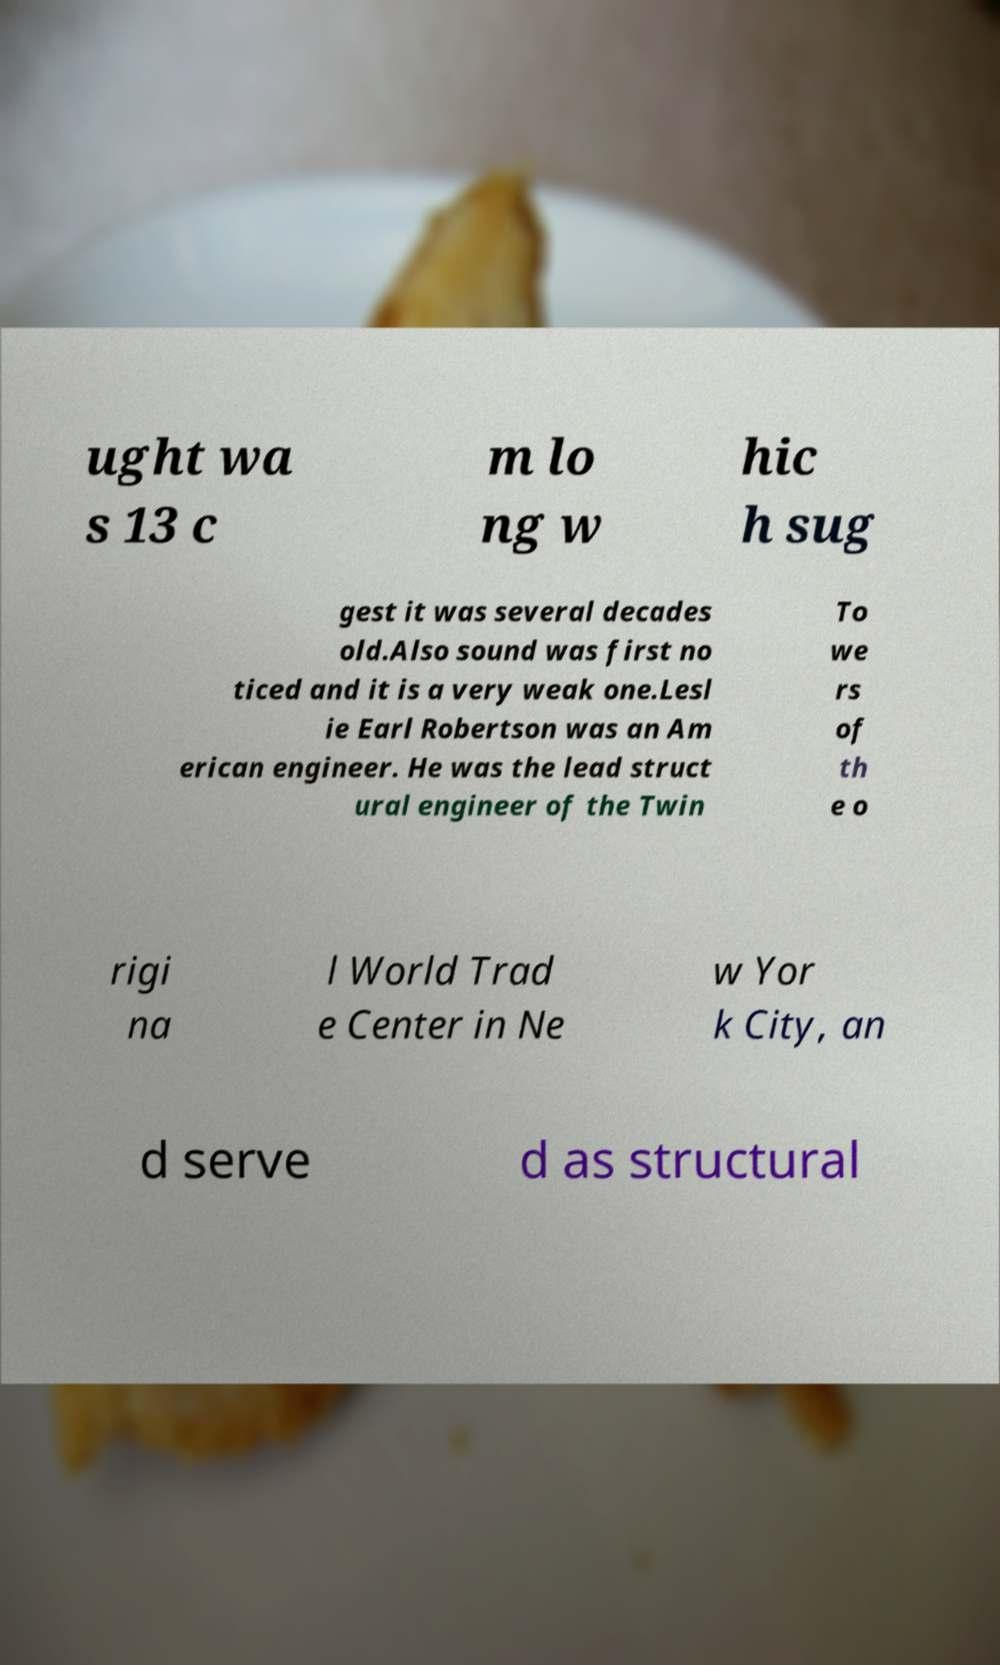Could you extract and type out the text from this image? ught wa s 13 c m lo ng w hic h sug gest it was several decades old.Also sound was first no ticed and it is a very weak one.Lesl ie Earl Robertson was an Am erican engineer. He was the lead struct ural engineer of the Twin To we rs of th e o rigi na l World Trad e Center in Ne w Yor k City, an d serve d as structural 